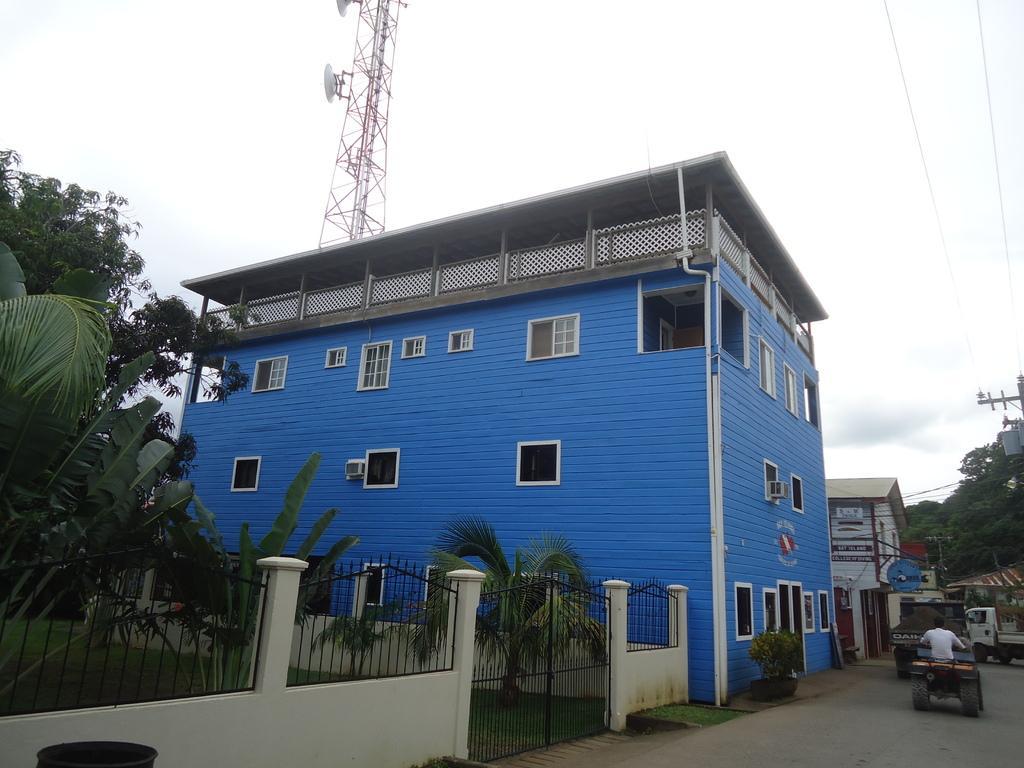Could you give a brief overview of what you see in this image? In this image we can see few buildings, there are some plants, trees, vehicles, grille, gate, wires, windows and a person, in the background we can see the sky. 